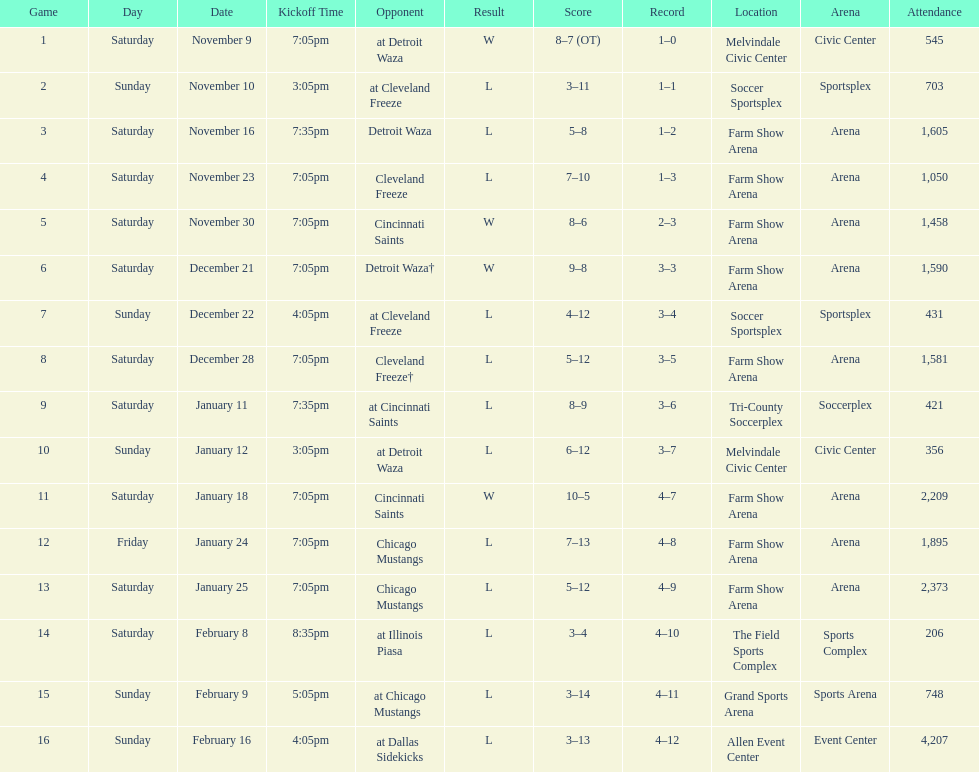How many times did the team play at home but did not win? 5. 